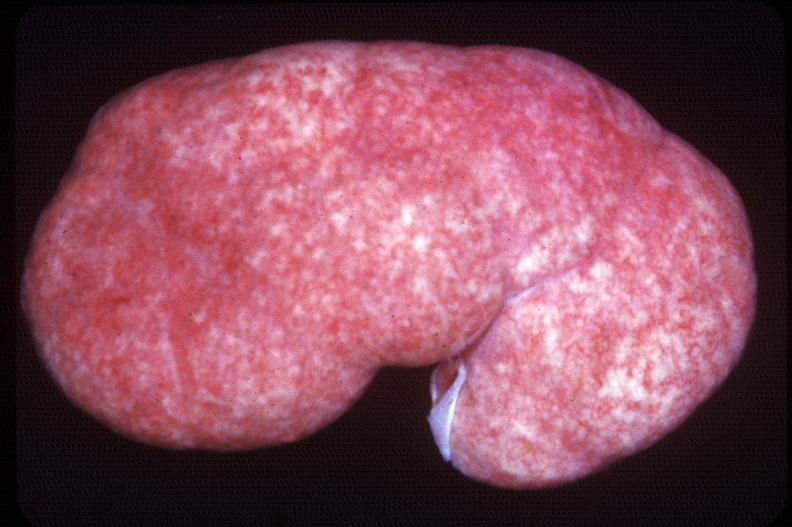does this image show kidney, pyelonephritis, acute and supperative?
Answer the question using a single word or phrase. Yes 